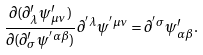<formula> <loc_0><loc_0><loc_500><loc_500>\frac { \partial ( \partial ^ { \prime } _ { \lambda } \psi ^ { \prime } _ { \mu \nu } ) } { \partial ( \partial ^ { \prime } _ { \sigma } \psi ^ { ^ { \prime } \alpha \beta } ) } \partial ^ { ^ { \prime } \lambda } \psi ^ { ^ { \prime } \mu \nu } = \partial ^ { ^ { \prime } \sigma } \psi ^ { \prime } _ { \alpha \beta } .</formula> 